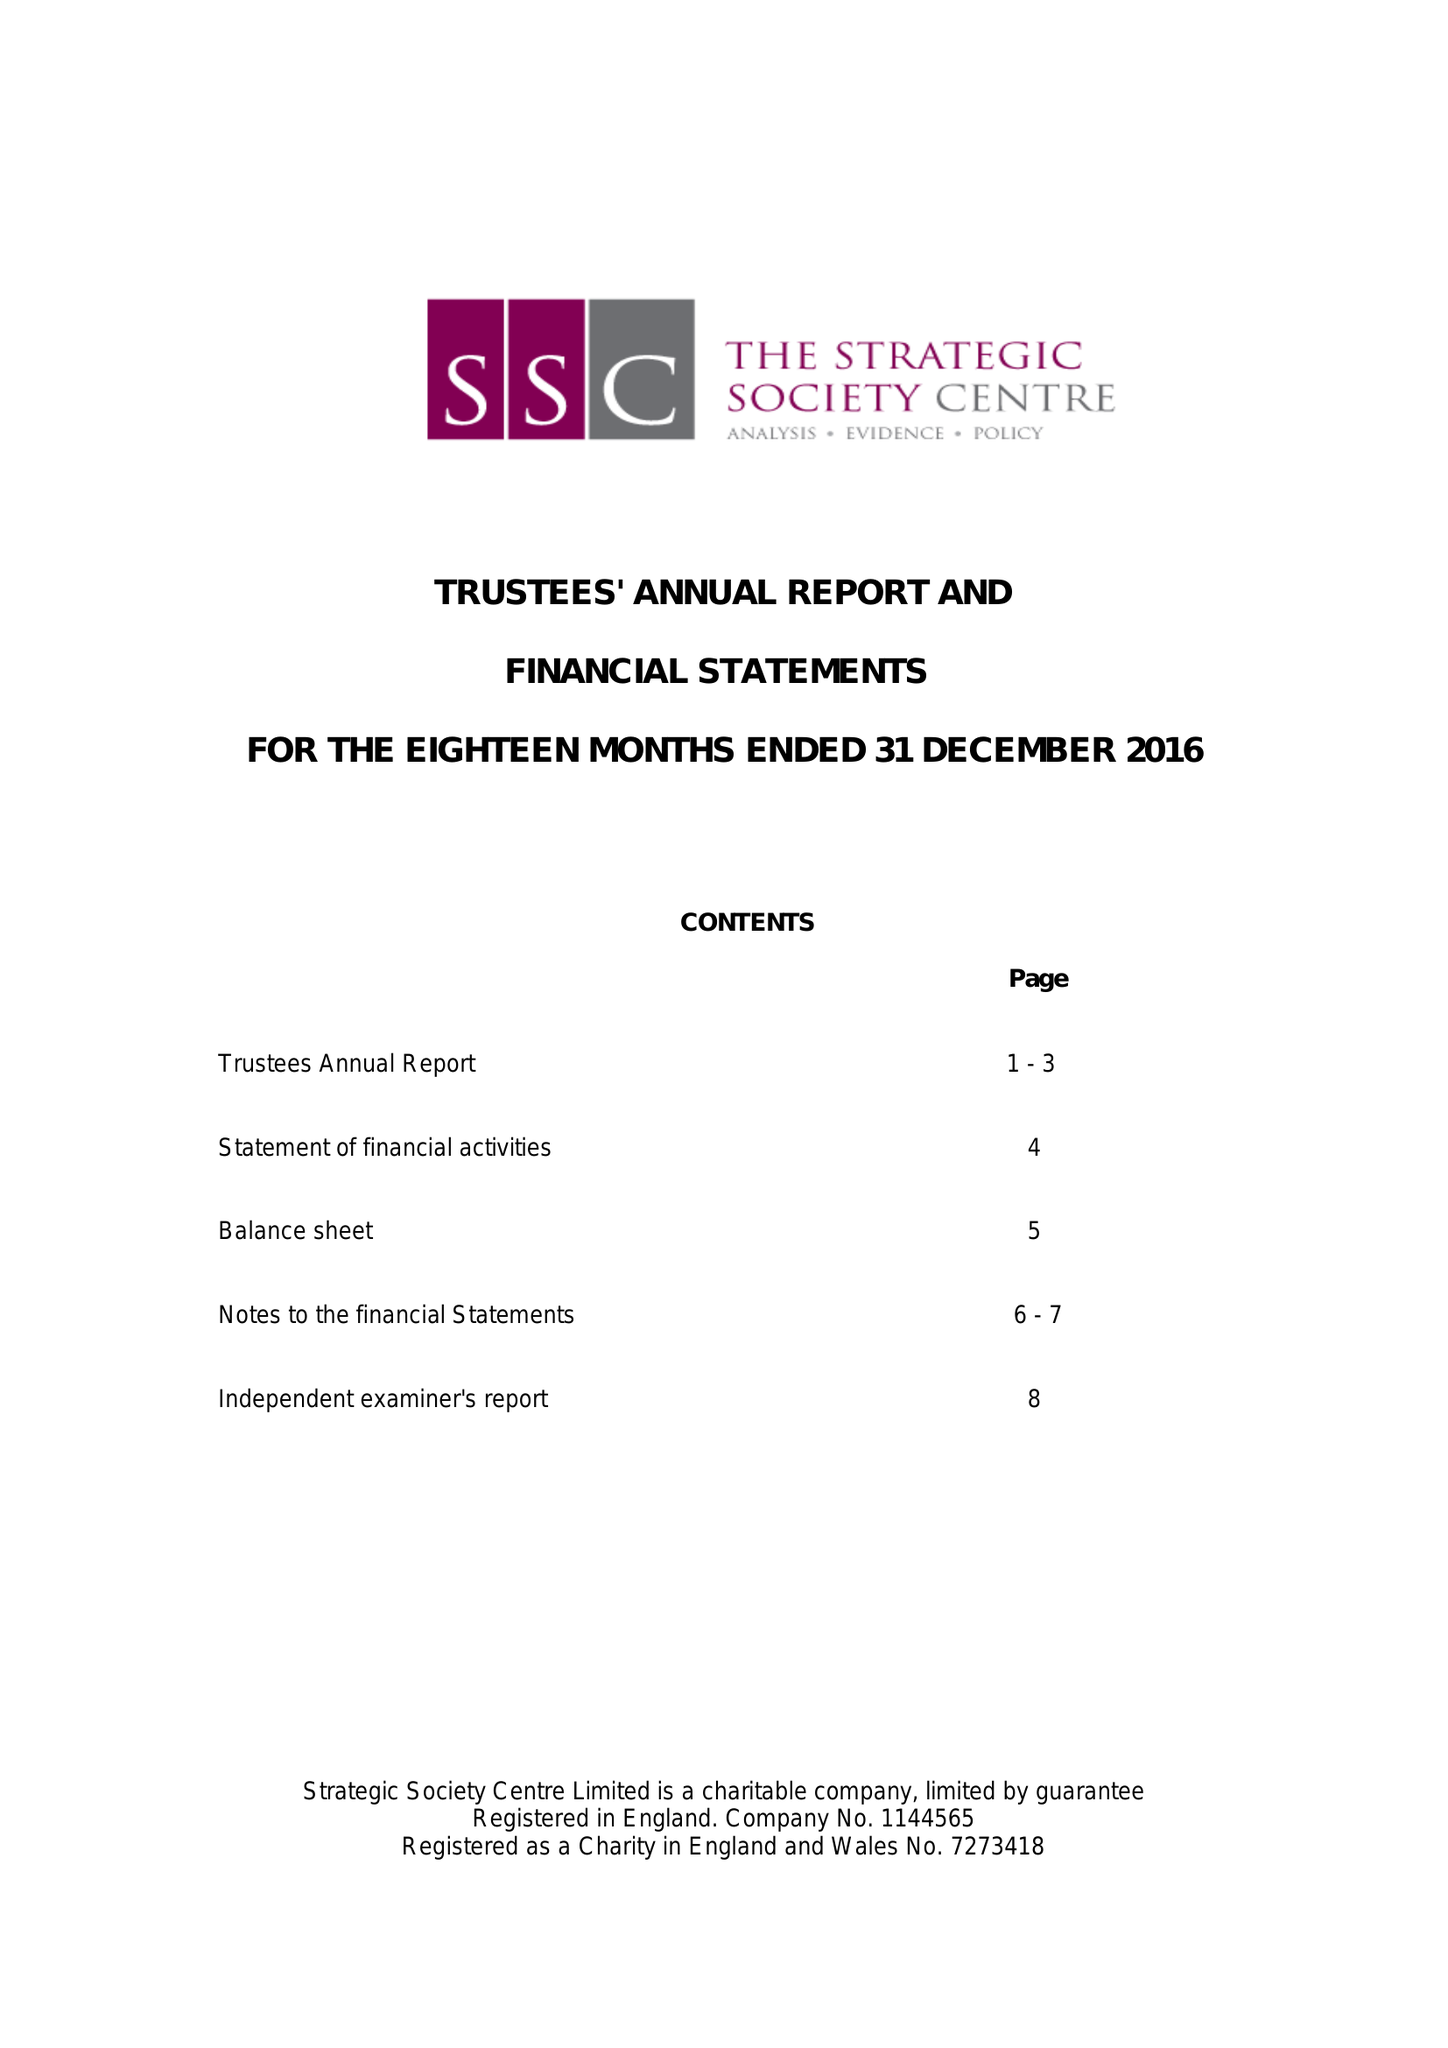What is the value for the report_date?
Answer the question using a single word or phrase. 2016-12-31 